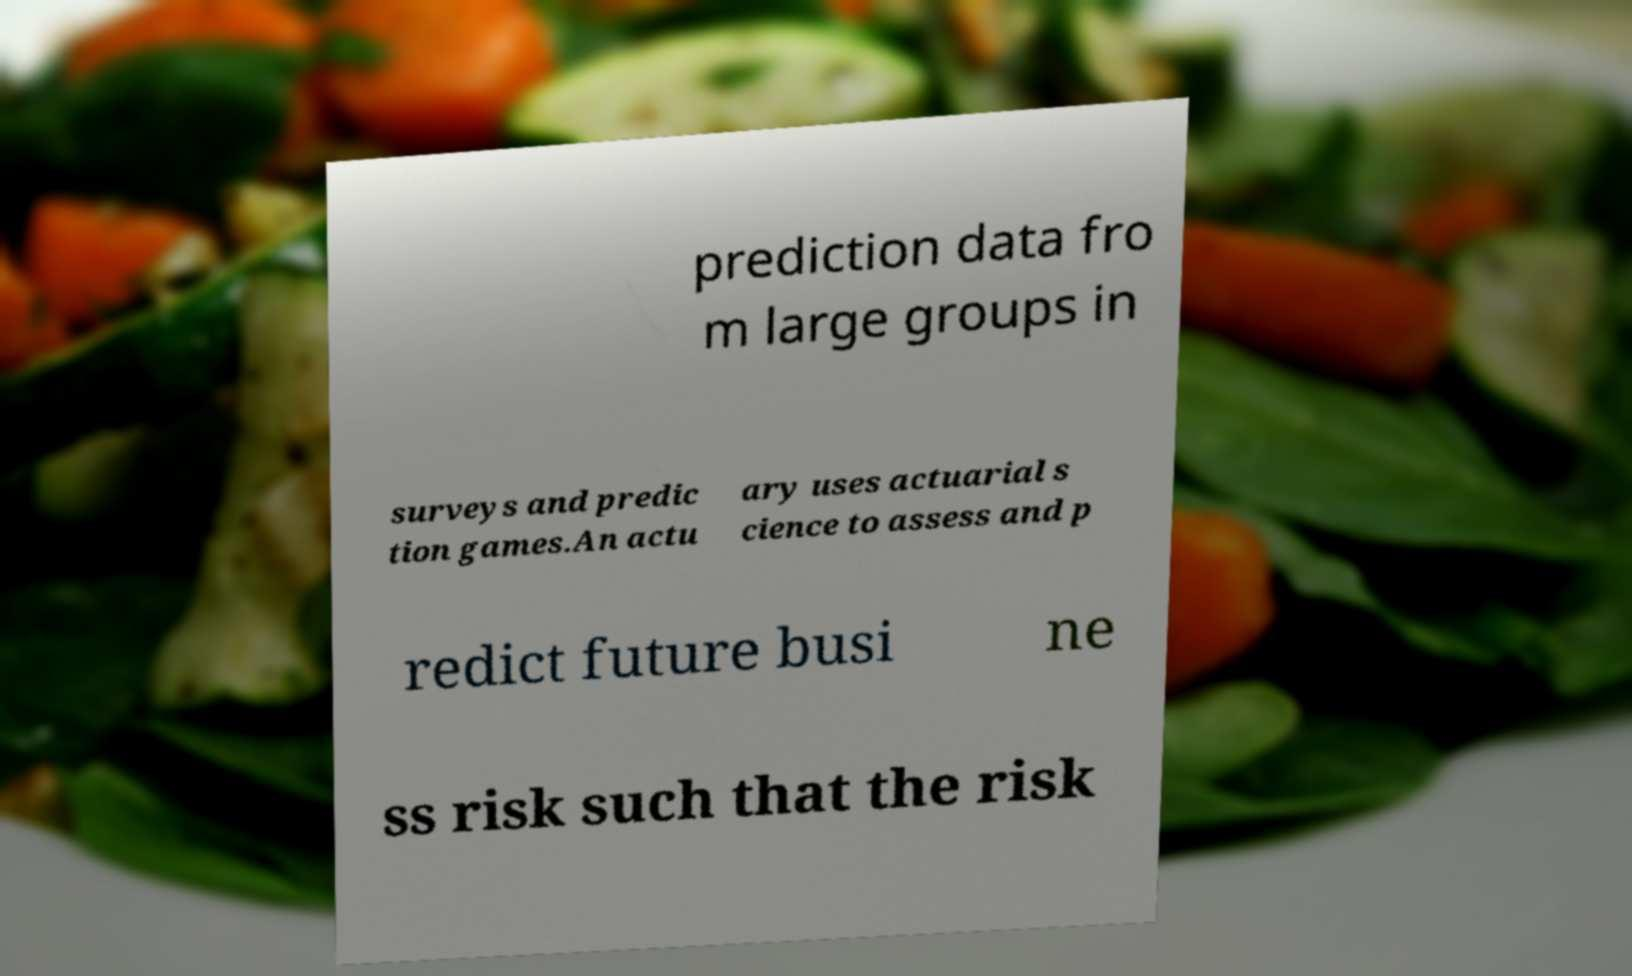What messages or text are displayed in this image? I need them in a readable, typed format. prediction data fro m large groups in surveys and predic tion games.An actu ary uses actuarial s cience to assess and p redict future busi ne ss risk such that the risk 